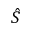<formula> <loc_0><loc_0><loc_500><loc_500>\hat { S }</formula> 